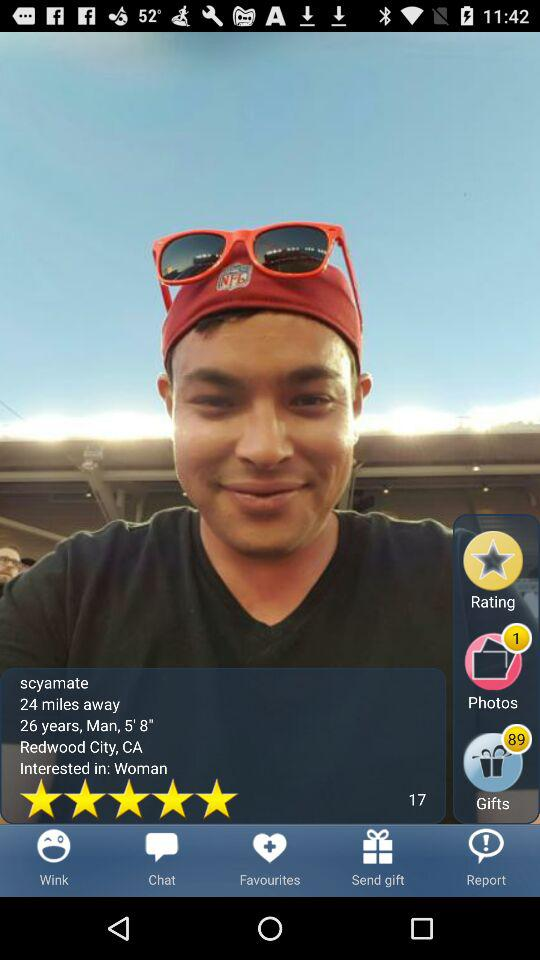What is the height? The height is 5 feet and 8 inches. 